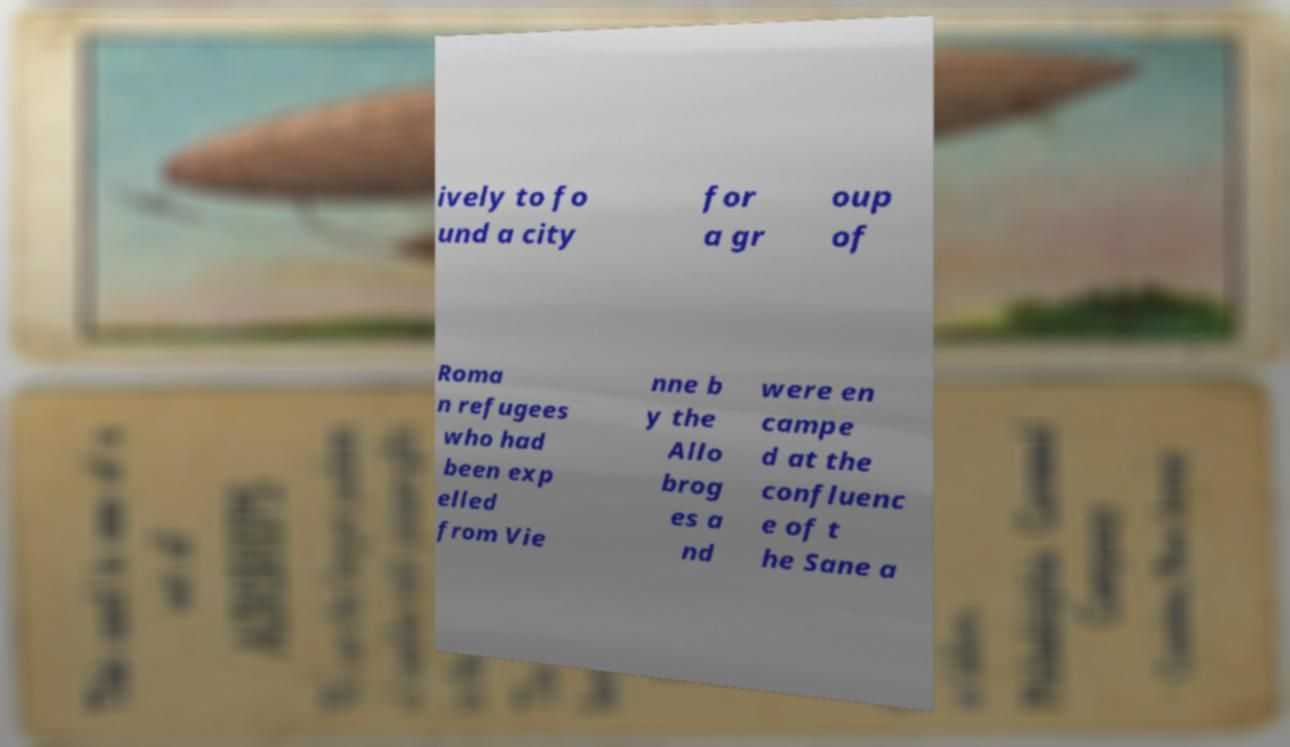What messages or text are displayed in this image? I need them in a readable, typed format. ively to fo und a city for a gr oup of Roma n refugees who had been exp elled from Vie nne b y the Allo brog es a nd were en campe d at the confluenc e of t he Sane a 